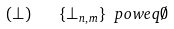<formula> <loc_0><loc_0><loc_500><loc_500>( \bot ) \quad \{ \bot _ { n , m } \} \ p o w e q \emptyset</formula> 